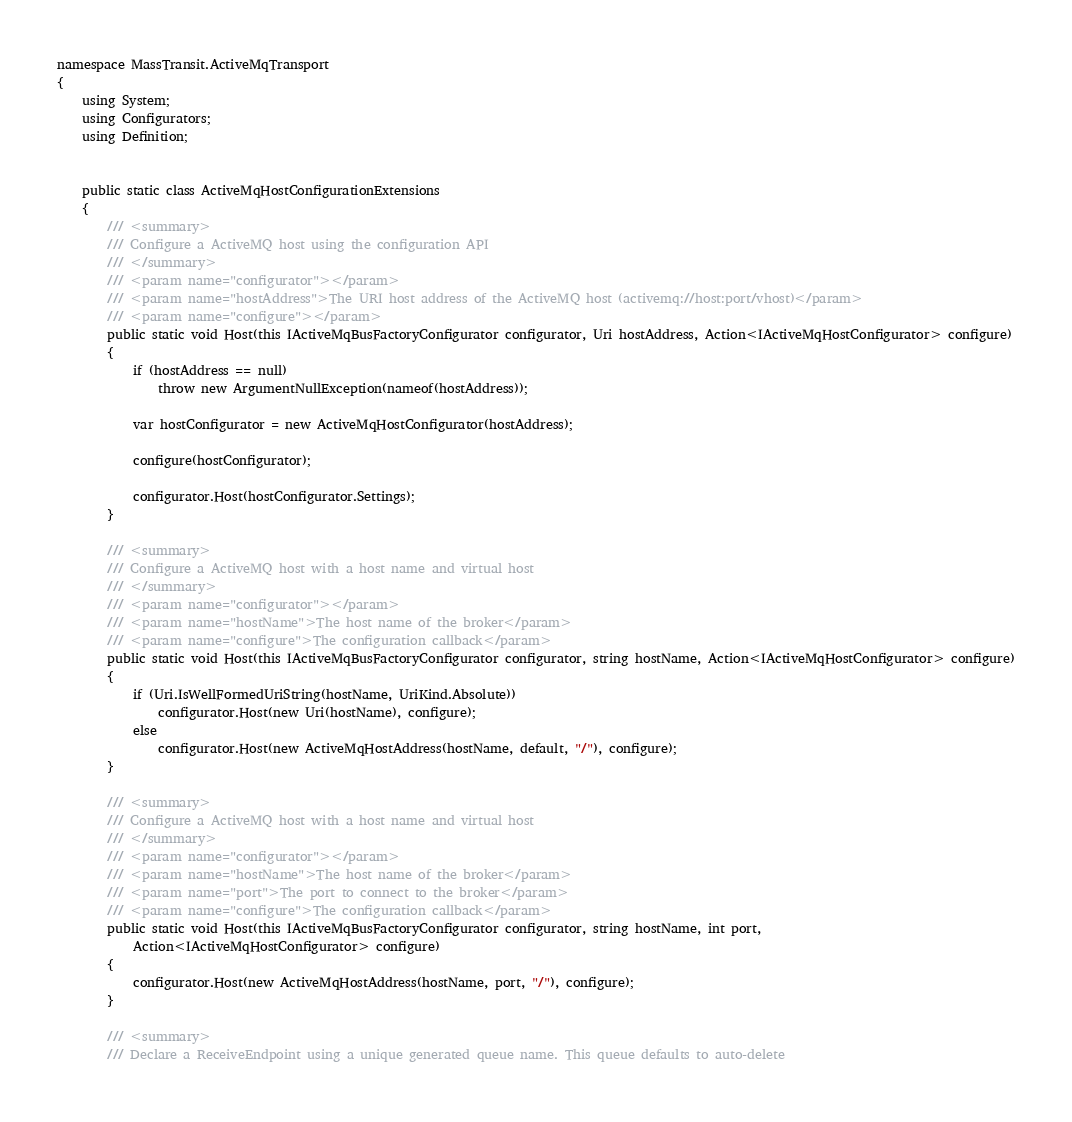<code> <loc_0><loc_0><loc_500><loc_500><_C#_>namespace MassTransit.ActiveMqTransport
{
    using System;
    using Configurators;
    using Definition;


    public static class ActiveMqHostConfigurationExtensions
    {
        /// <summary>
        /// Configure a ActiveMQ host using the configuration API
        /// </summary>
        /// <param name="configurator"></param>
        /// <param name="hostAddress">The URI host address of the ActiveMQ host (activemq://host:port/vhost)</param>
        /// <param name="configure"></param>
        public static void Host(this IActiveMqBusFactoryConfigurator configurator, Uri hostAddress, Action<IActiveMqHostConfigurator> configure)
        {
            if (hostAddress == null)
                throw new ArgumentNullException(nameof(hostAddress));

            var hostConfigurator = new ActiveMqHostConfigurator(hostAddress);

            configure(hostConfigurator);

            configurator.Host(hostConfigurator.Settings);
        }

        /// <summary>
        /// Configure a ActiveMQ host with a host name and virtual host
        /// </summary>
        /// <param name="configurator"></param>
        /// <param name="hostName">The host name of the broker</param>
        /// <param name="configure">The configuration callback</param>
        public static void Host(this IActiveMqBusFactoryConfigurator configurator, string hostName, Action<IActiveMqHostConfigurator> configure)
        {
            if (Uri.IsWellFormedUriString(hostName, UriKind.Absolute))
                configurator.Host(new Uri(hostName), configure);
            else
                configurator.Host(new ActiveMqHostAddress(hostName, default, "/"), configure);
        }

        /// <summary>
        /// Configure a ActiveMQ host with a host name and virtual host
        /// </summary>
        /// <param name="configurator"></param>
        /// <param name="hostName">The host name of the broker</param>
        /// <param name="port">The port to connect to the broker</param>
        /// <param name="configure">The configuration callback</param>
        public static void Host(this IActiveMqBusFactoryConfigurator configurator, string hostName, int port,
            Action<IActiveMqHostConfigurator> configure)
        {
            configurator.Host(new ActiveMqHostAddress(hostName, port, "/"), configure);
        }

        /// <summary>
        /// Declare a ReceiveEndpoint using a unique generated queue name. This queue defaults to auto-delete</code> 